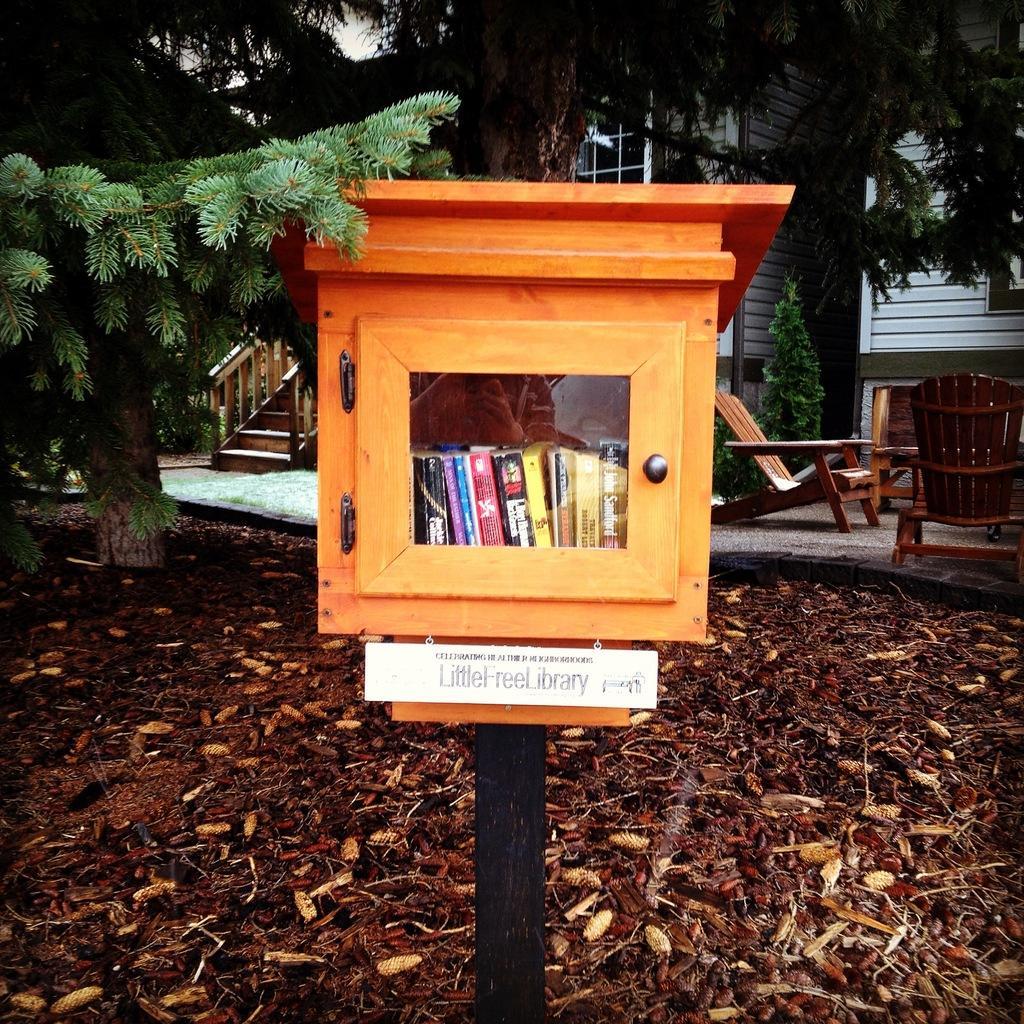Please provide a concise description of this image. This picture is clicked outside. In the center we can see a wooden cabinet containing books and we can see the text on a white color board and we can see there are some objects lying on the ground. In the background we can see the trees, houses, chairs, staircase, handrails and plants and some other objects. 